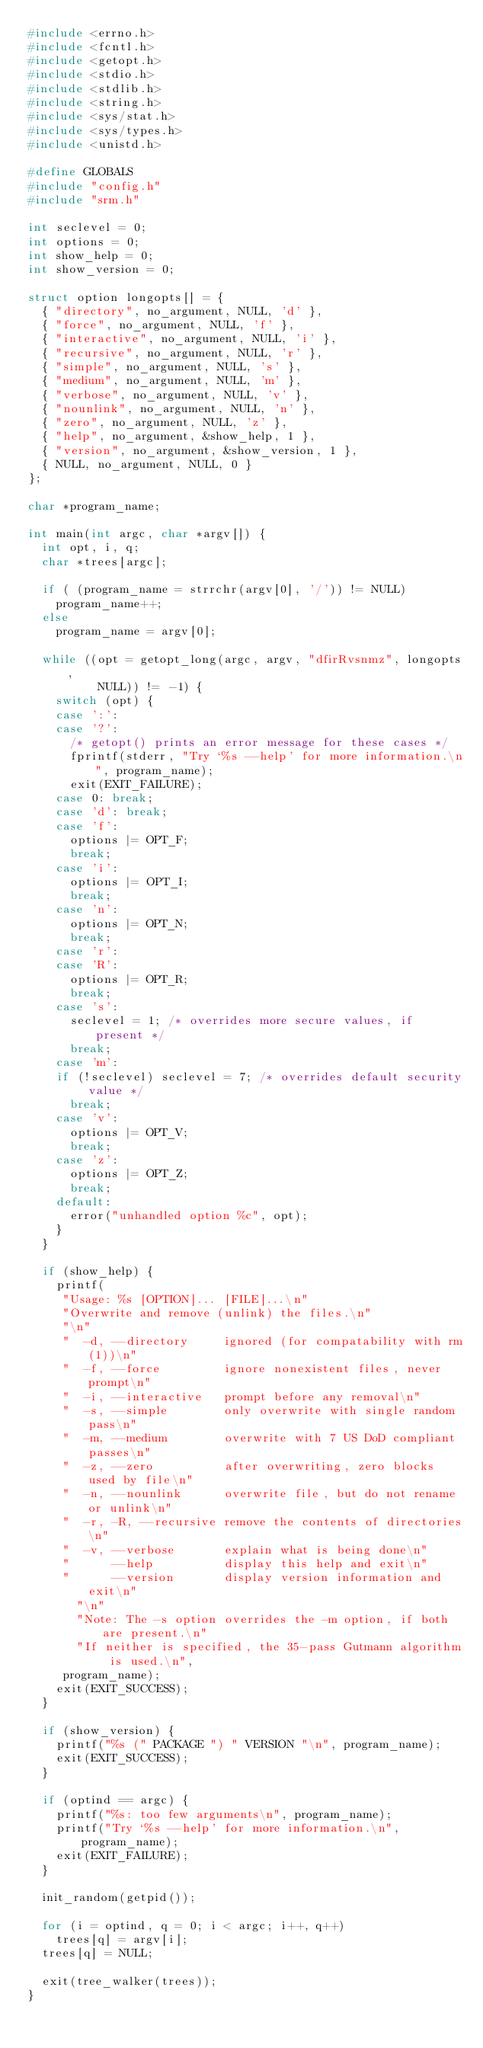<code> <loc_0><loc_0><loc_500><loc_500><_C_>#include <errno.h>
#include <fcntl.h>
#include <getopt.h>
#include <stdio.h>
#include <stdlib.h>
#include <string.h>
#include <sys/stat.h>
#include <sys/types.h>
#include <unistd.h>

#define GLOBALS
#include "config.h"
#include "srm.h"

int seclevel = 0;
int options = 0;
int show_help = 0;
int show_version = 0;

struct option longopts[] = {
  { "directory", no_argument, NULL, 'd' },
  { "force", no_argument, NULL, 'f' },
  { "interactive", no_argument, NULL, 'i' },
  { "recursive", no_argument, NULL, 'r' },
  { "simple", no_argument, NULL, 's' },
  { "medium", no_argument, NULL, 'm' },
  { "verbose", no_argument, NULL, 'v' },
  { "nounlink", no_argument, NULL, 'n' },
  { "zero", no_argument, NULL, 'z' },
  { "help", no_argument, &show_help, 1 },
  { "version", no_argument, &show_version, 1 },
  { NULL, no_argument, NULL, 0 }
};

char *program_name;

int main(int argc, char *argv[]) {
  int opt, i, q;
  char *trees[argc];

  if ( (program_name = strrchr(argv[0], '/')) != NULL)
    program_name++;
  else
    program_name = argv[0];

  while ((opt = getopt_long(argc, argv, "dfirRvsnmz", longopts,
			    NULL)) != -1) {
    switch (opt) {
    case ':': 
    case '?': 
      /* getopt() prints an error message for these cases */
      fprintf(stderr, "Try `%s --help' for more information.\n", program_name);
      exit(EXIT_FAILURE);
    case 0: break; 
    case 'd': break;
    case 'f': 
      options |= OPT_F;
      break;
    case 'i':
      options |= OPT_I;
      break;
    case 'n':
      options |= OPT_N;
      break;
    case 'r':
    case 'R':
      options |= OPT_R;
      break;
    case 's':
      seclevel = 1; /* overrides more secure values, if present */
      break;
    case 'm':
	  if (!seclevel) seclevel = 7; /* overrides default security value */
      break;
    case 'v':
      options |= OPT_V;
      break;
    case 'z':
      options |= OPT_Z;
      break;
    default:
      error("unhandled option %c", opt);
    }
  }

  if (show_help) {
    printf(
	   "Usage: %s [OPTION]... [FILE]...\n"
	   "Overwrite and remove (unlink) the files.\n"
	   "\n"
	   "  -d, --directory     ignored (for compatability with rm(1))\n"
	   "  -f, --force         ignore nonexistent files, never prompt\n"
	   "  -i, --interactive   prompt before any removal\n"
	   "  -s, --simple        only overwrite with single random pass\n"
	   "  -m, --medium        overwrite with 7 US DoD compliant passes\n"
	   "  -z, --zero          after overwriting, zero blocks used by file\n"
	   "  -n, --nounlink      overwrite file, but do not rename or unlink\n"
	   "  -r, -R, --recursive remove the contents of directories\n"
	   "  -v, --verbose       explain what is being done\n"
	   "      --help          display this help and exit\n"
	   "      --version       display version information and exit\n"
       "\n"
       "Note: The -s option overrides the -m option, if both are present.\n"
       "If neither is specified, the 35-pass Gutmann algorithm is used.\n",
	   program_name);
    exit(EXIT_SUCCESS);
  }

  if (show_version) {
    printf("%s (" PACKAGE ") " VERSION "\n", program_name);
    exit(EXIT_SUCCESS);
  }

  if (optind == argc) {
    printf("%s: too few arguments\n", program_name);
    printf("Try `%s --help' for more information.\n", program_name);
    exit(EXIT_FAILURE);
  }

  init_random(getpid());

  for (i = optind, q = 0; i < argc; i++, q++) 
    trees[q] = argv[i];
  trees[q] = NULL;

  exit(tree_walker(trees));
}
</code> 